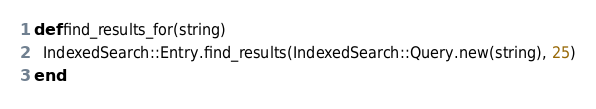<code> <loc_0><loc_0><loc_500><loc_500><_Ruby_>def find_results_for(string)
  IndexedSearch::Entry.find_results(IndexedSearch::Query.new(string), 25)
end
</code> 